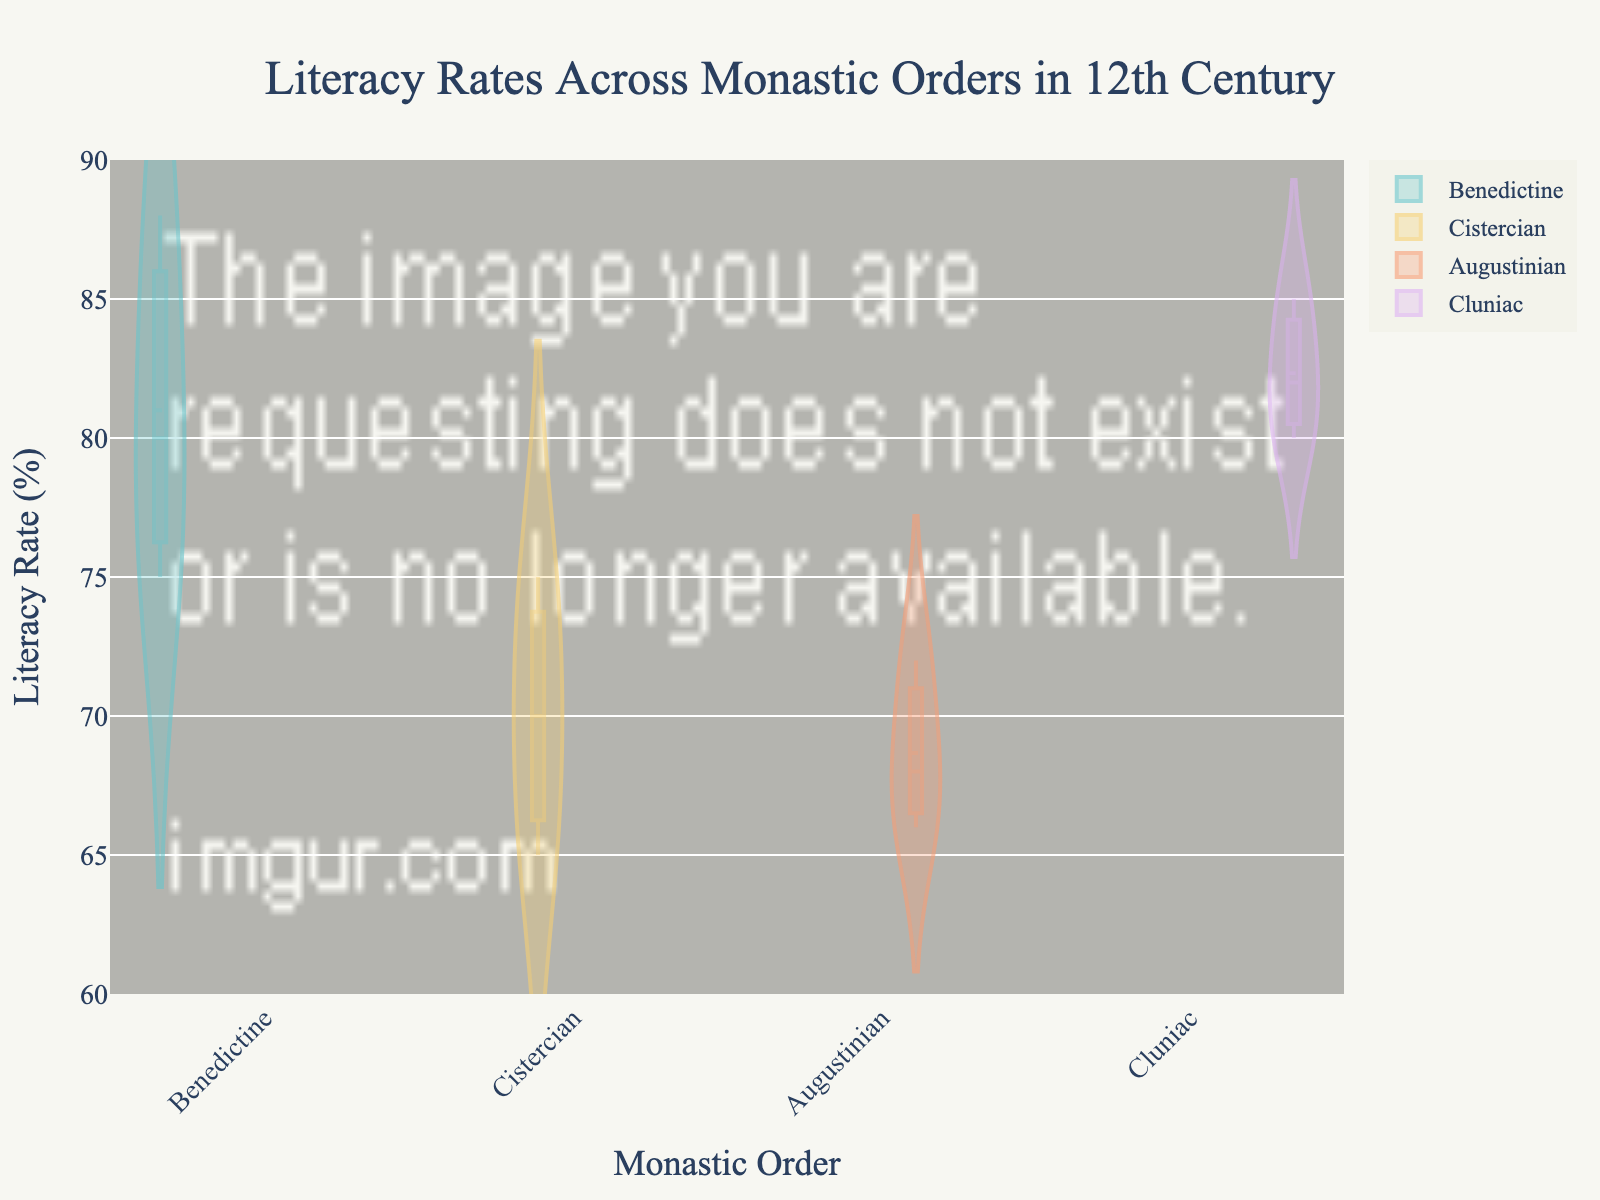What is the title of the figure? The title of the figure is usually displayed at the top center. In this figure, it should be clearly readable.
Answer: Literacy Rates Across Monastic Orders in 12th Century Which monastic order has the highest mean literacy rate? The mean literacy rate for each order can be observed from the mean line inside the violin plot. By comparing these lines across orders, we find the highest one.
Answer: Benedictine What is the range of literacy rates for the Cistercian order? The range of literacy rates is determined by looking at the top and bottom points of the violin plot for the Cistercian order. This can be observed directly from the Cistercian section of the figure.
Answer: 65% to 75% How many monastic orders are compared in the figure? The distinct orders are shown along the x-axis. Counting the unique labels gives us the number of orders.
Answer: 4 What is the median literacy rate for the Augustinian order? The median literacy rate is shown by the middle line in the box plot overlay within the violin plot. Look at the median for Augustinian specifically.
Answer: 68% Which monastic order shows the greatest variability in literacy rates? The variability can be identified by the width and spread of the violin plot. The order with the widest and most spread-out plot indicates the greatest variability.
Answer: Cistercian Compare the 75th percentile of literacy rates between the Benedictine and Cluniac orders. Which is higher? The 75th percentile can be identified by the top line of the box within each violin plot. Comparing these lines for Benedictine and Cluniac shows which one is higher.
Answer: Benedictine What is the literacy rate for the Cluniac order at La Charité-sur-Loire? Specific data points can be located based on the position within their respective violin plots. For Cluniac at La Charité-sur-Loire, find the specific point within the Cluniac plot.
Answer: 82% Based on the figure, which order has the least skewed distribution in literacy rates? The skewness can be inferred from the symmetry of the violin plot. The order with the most symmetrical plot, with a mean line close to the median, is the least skewed.
Answer: Benedictine How does the literacy rate at Westminster Abbey for the Benedictine order compare to the mean rate of the same order? Identify the literacy rate for Westminster Abbey within the Benedictine plot and compare it to the mean line within the same plot. The rate is 75%, which is compared to the Benedictine mean rate.
Answer: 75% is below the mean 